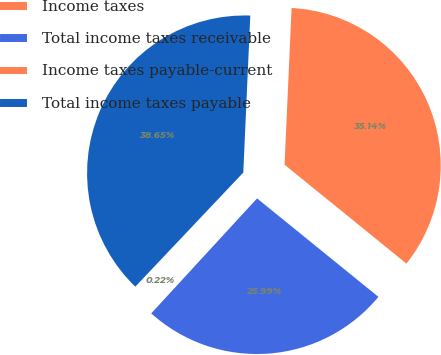Convert chart. <chart><loc_0><loc_0><loc_500><loc_500><pie_chart><fcel>Income taxes<fcel>Total income taxes receivable<fcel>Income taxes payable-current<fcel>Total income taxes payable<nl><fcel>0.22%<fcel>25.99%<fcel>35.14%<fcel>38.65%<nl></chart> 